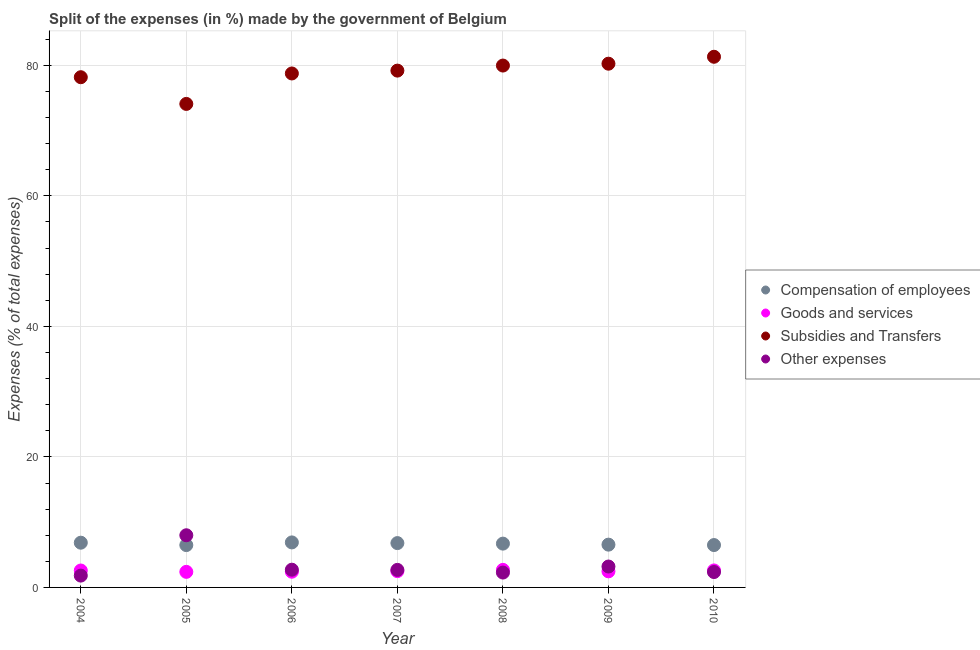How many different coloured dotlines are there?
Your answer should be very brief. 4. What is the percentage of amount spent on compensation of employees in 2005?
Provide a short and direct response. 6.49. Across all years, what is the maximum percentage of amount spent on subsidies?
Offer a terse response. 81.32. Across all years, what is the minimum percentage of amount spent on compensation of employees?
Give a very brief answer. 6.49. In which year was the percentage of amount spent on goods and services maximum?
Keep it short and to the point. 2008. In which year was the percentage of amount spent on compensation of employees minimum?
Make the answer very short. 2005. What is the total percentage of amount spent on goods and services in the graph?
Ensure brevity in your answer.  17.65. What is the difference between the percentage of amount spent on goods and services in 2006 and that in 2007?
Make the answer very short. -0.09. What is the difference between the percentage of amount spent on goods and services in 2010 and the percentage of amount spent on subsidies in 2006?
Keep it short and to the point. -76.16. What is the average percentage of amount spent on subsidies per year?
Your answer should be very brief. 78.83. In the year 2010, what is the difference between the percentage of amount spent on compensation of employees and percentage of amount spent on goods and services?
Offer a terse response. 3.89. In how many years, is the percentage of amount spent on compensation of employees greater than 76 %?
Your response must be concise. 0. What is the ratio of the percentage of amount spent on other expenses in 2006 to that in 2008?
Offer a terse response. 1.19. Is the percentage of amount spent on compensation of employees in 2004 less than that in 2007?
Make the answer very short. No. What is the difference between the highest and the second highest percentage of amount spent on goods and services?
Your response must be concise. 0.09. What is the difference between the highest and the lowest percentage of amount spent on goods and services?
Provide a succinct answer. 0.3. Is it the case that in every year, the sum of the percentage of amount spent on other expenses and percentage of amount spent on subsidies is greater than the sum of percentage of amount spent on goods and services and percentage of amount spent on compensation of employees?
Offer a terse response. Yes. Does the percentage of amount spent on compensation of employees monotonically increase over the years?
Your answer should be compact. No. How many years are there in the graph?
Provide a short and direct response. 7. What is the difference between two consecutive major ticks on the Y-axis?
Ensure brevity in your answer.  20. Are the values on the major ticks of Y-axis written in scientific E-notation?
Your answer should be very brief. No. Does the graph contain any zero values?
Your answer should be compact. No. How many legend labels are there?
Provide a short and direct response. 4. What is the title of the graph?
Ensure brevity in your answer.  Split of the expenses (in %) made by the government of Belgium. What is the label or title of the Y-axis?
Provide a short and direct response. Expenses (% of total expenses). What is the Expenses (% of total expenses) in Compensation of employees in 2004?
Your answer should be very brief. 6.85. What is the Expenses (% of total expenses) in Goods and services in 2004?
Your response must be concise. 2.59. What is the Expenses (% of total expenses) of Subsidies and Transfers in 2004?
Provide a short and direct response. 78.19. What is the Expenses (% of total expenses) in Other expenses in 2004?
Give a very brief answer. 1.81. What is the Expenses (% of total expenses) in Compensation of employees in 2005?
Your answer should be very brief. 6.49. What is the Expenses (% of total expenses) of Goods and services in 2005?
Provide a short and direct response. 2.39. What is the Expenses (% of total expenses) of Subsidies and Transfers in 2005?
Keep it short and to the point. 74.09. What is the Expenses (% of total expenses) of Other expenses in 2005?
Provide a succinct answer. 7.99. What is the Expenses (% of total expenses) of Compensation of employees in 2006?
Offer a very short reply. 6.9. What is the Expenses (% of total expenses) in Goods and services in 2006?
Provide a short and direct response. 2.41. What is the Expenses (% of total expenses) of Subsidies and Transfers in 2006?
Give a very brief answer. 78.76. What is the Expenses (% of total expenses) in Other expenses in 2006?
Keep it short and to the point. 2.72. What is the Expenses (% of total expenses) in Compensation of employees in 2007?
Your answer should be compact. 6.79. What is the Expenses (% of total expenses) in Goods and services in 2007?
Your response must be concise. 2.5. What is the Expenses (% of total expenses) in Subsidies and Transfers in 2007?
Your answer should be compact. 79.2. What is the Expenses (% of total expenses) of Other expenses in 2007?
Give a very brief answer. 2.69. What is the Expenses (% of total expenses) in Compensation of employees in 2008?
Make the answer very short. 6.71. What is the Expenses (% of total expenses) in Goods and services in 2008?
Offer a very short reply. 2.69. What is the Expenses (% of total expenses) in Subsidies and Transfers in 2008?
Your answer should be very brief. 79.97. What is the Expenses (% of total expenses) of Other expenses in 2008?
Your answer should be compact. 2.28. What is the Expenses (% of total expenses) in Compensation of employees in 2009?
Offer a terse response. 6.56. What is the Expenses (% of total expenses) of Goods and services in 2009?
Offer a very short reply. 2.47. What is the Expenses (% of total expenses) of Subsidies and Transfers in 2009?
Offer a very short reply. 80.26. What is the Expenses (% of total expenses) in Other expenses in 2009?
Your answer should be compact. 3.2. What is the Expenses (% of total expenses) of Compensation of employees in 2010?
Ensure brevity in your answer.  6.49. What is the Expenses (% of total expenses) of Goods and services in 2010?
Make the answer very short. 2.6. What is the Expenses (% of total expenses) of Subsidies and Transfers in 2010?
Make the answer very short. 81.32. What is the Expenses (% of total expenses) in Other expenses in 2010?
Give a very brief answer. 2.36. Across all years, what is the maximum Expenses (% of total expenses) in Compensation of employees?
Make the answer very short. 6.9. Across all years, what is the maximum Expenses (% of total expenses) of Goods and services?
Ensure brevity in your answer.  2.69. Across all years, what is the maximum Expenses (% of total expenses) of Subsidies and Transfers?
Ensure brevity in your answer.  81.32. Across all years, what is the maximum Expenses (% of total expenses) in Other expenses?
Provide a short and direct response. 7.99. Across all years, what is the minimum Expenses (% of total expenses) in Compensation of employees?
Ensure brevity in your answer.  6.49. Across all years, what is the minimum Expenses (% of total expenses) in Goods and services?
Your answer should be compact. 2.39. Across all years, what is the minimum Expenses (% of total expenses) in Subsidies and Transfers?
Make the answer very short. 74.09. Across all years, what is the minimum Expenses (% of total expenses) of Other expenses?
Give a very brief answer. 1.81. What is the total Expenses (% of total expenses) of Compensation of employees in the graph?
Make the answer very short. 46.8. What is the total Expenses (% of total expenses) in Goods and services in the graph?
Keep it short and to the point. 17.65. What is the total Expenses (% of total expenses) of Subsidies and Transfers in the graph?
Your answer should be very brief. 551.78. What is the total Expenses (% of total expenses) of Other expenses in the graph?
Make the answer very short. 23.05. What is the difference between the Expenses (% of total expenses) in Compensation of employees in 2004 and that in 2005?
Make the answer very short. 0.37. What is the difference between the Expenses (% of total expenses) of Goods and services in 2004 and that in 2005?
Your answer should be very brief. 0.21. What is the difference between the Expenses (% of total expenses) of Subsidies and Transfers in 2004 and that in 2005?
Your response must be concise. 4.09. What is the difference between the Expenses (% of total expenses) in Other expenses in 2004 and that in 2005?
Keep it short and to the point. -6.18. What is the difference between the Expenses (% of total expenses) in Compensation of employees in 2004 and that in 2006?
Make the answer very short. -0.04. What is the difference between the Expenses (% of total expenses) of Goods and services in 2004 and that in 2006?
Your answer should be compact. 0.18. What is the difference between the Expenses (% of total expenses) in Subsidies and Transfers in 2004 and that in 2006?
Provide a short and direct response. -0.57. What is the difference between the Expenses (% of total expenses) of Other expenses in 2004 and that in 2006?
Your response must be concise. -0.91. What is the difference between the Expenses (% of total expenses) in Compensation of employees in 2004 and that in 2007?
Keep it short and to the point. 0.06. What is the difference between the Expenses (% of total expenses) in Goods and services in 2004 and that in 2007?
Your answer should be compact. 0.09. What is the difference between the Expenses (% of total expenses) in Subsidies and Transfers in 2004 and that in 2007?
Offer a very short reply. -1.01. What is the difference between the Expenses (% of total expenses) of Other expenses in 2004 and that in 2007?
Keep it short and to the point. -0.88. What is the difference between the Expenses (% of total expenses) in Compensation of employees in 2004 and that in 2008?
Ensure brevity in your answer.  0.14. What is the difference between the Expenses (% of total expenses) in Goods and services in 2004 and that in 2008?
Make the answer very short. -0.1. What is the difference between the Expenses (% of total expenses) in Subsidies and Transfers in 2004 and that in 2008?
Your response must be concise. -1.79. What is the difference between the Expenses (% of total expenses) of Other expenses in 2004 and that in 2008?
Keep it short and to the point. -0.47. What is the difference between the Expenses (% of total expenses) in Compensation of employees in 2004 and that in 2009?
Give a very brief answer. 0.3. What is the difference between the Expenses (% of total expenses) of Goods and services in 2004 and that in 2009?
Your answer should be very brief. 0.13. What is the difference between the Expenses (% of total expenses) in Subsidies and Transfers in 2004 and that in 2009?
Your response must be concise. -2.07. What is the difference between the Expenses (% of total expenses) in Other expenses in 2004 and that in 2009?
Provide a succinct answer. -1.39. What is the difference between the Expenses (% of total expenses) of Compensation of employees in 2004 and that in 2010?
Your answer should be very brief. 0.36. What is the difference between the Expenses (% of total expenses) of Goods and services in 2004 and that in 2010?
Your answer should be compact. -0.01. What is the difference between the Expenses (% of total expenses) of Subsidies and Transfers in 2004 and that in 2010?
Offer a terse response. -3.13. What is the difference between the Expenses (% of total expenses) in Other expenses in 2004 and that in 2010?
Keep it short and to the point. -0.54. What is the difference between the Expenses (% of total expenses) of Compensation of employees in 2005 and that in 2006?
Your answer should be very brief. -0.41. What is the difference between the Expenses (% of total expenses) of Goods and services in 2005 and that in 2006?
Your answer should be compact. -0.02. What is the difference between the Expenses (% of total expenses) in Subsidies and Transfers in 2005 and that in 2006?
Offer a terse response. -4.67. What is the difference between the Expenses (% of total expenses) of Other expenses in 2005 and that in 2006?
Give a very brief answer. 5.28. What is the difference between the Expenses (% of total expenses) of Compensation of employees in 2005 and that in 2007?
Provide a succinct answer. -0.31. What is the difference between the Expenses (% of total expenses) in Goods and services in 2005 and that in 2007?
Keep it short and to the point. -0.11. What is the difference between the Expenses (% of total expenses) of Subsidies and Transfers in 2005 and that in 2007?
Ensure brevity in your answer.  -5.1. What is the difference between the Expenses (% of total expenses) in Other expenses in 2005 and that in 2007?
Offer a terse response. 5.31. What is the difference between the Expenses (% of total expenses) in Compensation of employees in 2005 and that in 2008?
Give a very brief answer. -0.22. What is the difference between the Expenses (% of total expenses) of Goods and services in 2005 and that in 2008?
Provide a succinct answer. -0.3. What is the difference between the Expenses (% of total expenses) in Subsidies and Transfers in 2005 and that in 2008?
Give a very brief answer. -5.88. What is the difference between the Expenses (% of total expenses) of Other expenses in 2005 and that in 2008?
Provide a succinct answer. 5.72. What is the difference between the Expenses (% of total expenses) in Compensation of employees in 2005 and that in 2009?
Give a very brief answer. -0.07. What is the difference between the Expenses (% of total expenses) in Goods and services in 2005 and that in 2009?
Keep it short and to the point. -0.08. What is the difference between the Expenses (% of total expenses) in Subsidies and Transfers in 2005 and that in 2009?
Offer a terse response. -6.16. What is the difference between the Expenses (% of total expenses) in Other expenses in 2005 and that in 2009?
Make the answer very short. 4.79. What is the difference between the Expenses (% of total expenses) in Compensation of employees in 2005 and that in 2010?
Offer a very short reply. -0. What is the difference between the Expenses (% of total expenses) of Goods and services in 2005 and that in 2010?
Ensure brevity in your answer.  -0.22. What is the difference between the Expenses (% of total expenses) in Subsidies and Transfers in 2005 and that in 2010?
Your answer should be compact. -7.23. What is the difference between the Expenses (% of total expenses) in Other expenses in 2005 and that in 2010?
Keep it short and to the point. 5.64. What is the difference between the Expenses (% of total expenses) of Compensation of employees in 2006 and that in 2007?
Give a very brief answer. 0.1. What is the difference between the Expenses (% of total expenses) of Goods and services in 2006 and that in 2007?
Offer a terse response. -0.09. What is the difference between the Expenses (% of total expenses) in Subsidies and Transfers in 2006 and that in 2007?
Ensure brevity in your answer.  -0.44. What is the difference between the Expenses (% of total expenses) in Other expenses in 2006 and that in 2007?
Provide a succinct answer. 0.03. What is the difference between the Expenses (% of total expenses) of Compensation of employees in 2006 and that in 2008?
Your response must be concise. 0.19. What is the difference between the Expenses (% of total expenses) of Goods and services in 2006 and that in 2008?
Give a very brief answer. -0.28. What is the difference between the Expenses (% of total expenses) of Subsidies and Transfers in 2006 and that in 2008?
Keep it short and to the point. -1.21. What is the difference between the Expenses (% of total expenses) of Other expenses in 2006 and that in 2008?
Keep it short and to the point. 0.44. What is the difference between the Expenses (% of total expenses) in Compensation of employees in 2006 and that in 2009?
Provide a succinct answer. 0.34. What is the difference between the Expenses (% of total expenses) in Goods and services in 2006 and that in 2009?
Provide a short and direct response. -0.06. What is the difference between the Expenses (% of total expenses) in Subsidies and Transfers in 2006 and that in 2009?
Offer a terse response. -1.5. What is the difference between the Expenses (% of total expenses) in Other expenses in 2006 and that in 2009?
Make the answer very short. -0.49. What is the difference between the Expenses (% of total expenses) in Compensation of employees in 2006 and that in 2010?
Provide a succinct answer. 0.41. What is the difference between the Expenses (% of total expenses) of Goods and services in 2006 and that in 2010?
Keep it short and to the point. -0.19. What is the difference between the Expenses (% of total expenses) in Subsidies and Transfers in 2006 and that in 2010?
Provide a succinct answer. -2.56. What is the difference between the Expenses (% of total expenses) in Other expenses in 2006 and that in 2010?
Provide a succinct answer. 0.36. What is the difference between the Expenses (% of total expenses) of Compensation of employees in 2007 and that in 2008?
Your response must be concise. 0.08. What is the difference between the Expenses (% of total expenses) of Goods and services in 2007 and that in 2008?
Keep it short and to the point. -0.19. What is the difference between the Expenses (% of total expenses) of Subsidies and Transfers in 2007 and that in 2008?
Your answer should be very brief. -0.77. What is the difference between the Expenses (% of total expenses) in Other expenses in 2007 and that in 2008?
Your response must be concise. 0.41. What is the difference between the Expenses (% of total expenses) of Compensation of employees in 2007 and that in 2009?
Your response must be concise. 0.24. What is the difference between the Expenses (% of total expenses) in Goods and services in 2007 and that in 2009?
Offer a terse response. 0.03. What is the difference between the Expenses (% of total expenses) of Subsidies and Transfers in 2007 and that in 2009?
Provide a succinct answer. -1.06. What is the difference between the Expenses (% of total expenses) in Other expenses in 2007 and that in 2009?
Keep it short and to the point. -0.52. What is the difference between the Expenses (% of total expenses) in Compensation of employees in 2007 and that in 2010?
Give a very brief answer. 0.3. What is the difference between the Expenses (% of total expenses) in Goods and services in 2007 and that in 2010?
Offer a terse response. -0.1. What is the difference between the Expenses (% of total expenses) of Subsidies and Transfers in 2007 and that in 2010?
Provide a short and direct response. -2.12. What is the difference between the Expenses (% of total expenses) in Other expenses in 2007 and that in 2010?
Provide a succinct answer. 0.33. What is the difference between the Expenses (% of total expenses) in Compensation of employees in 2008 and that in 2009?
Your answer should be very brief. 0.16. What is the difference between the Expenses (% of total expenses) in Goods and services in 2008 and that in 2009?
Offer a very short reply. 0.22. What is the difference between the Expenses (% of total expenses) of Subsidies and Transfers in 2008 and that in 2009?
Ensure brevity in your answer.  -0.29. What is the difference between the Expenses (% of total expenses) in Other expenses in 2008 and that in 2009?
Ensure brevity in your answer.  -0.93. What is the difference between the Expenses (% of total expenses) in Compensation of employees in 2008 and that in 2010?
Ensure brevity in your answer.  0.22. What is the difference between the Expenses (% of total expenses) of Goods and services in 2008 and that in 2010?
Your answer should be compact. 0.09. What is the difference between the Expenses (% of total expenses) in Subsidies and Transfers in 2008 and that in 2010?
Offer a very short reply. -1.35. What is the difference between the Expenses (% of total expenses) of Other expenses in 2008 and that in 2010?
Make the answer very short. -0.08. What is the difference between the Expenses (% of total expenses) of Compensation of employees in 2009 and that in 2010?
Ensure brevity in your answer.  0.06. What is the difference between the Expenses (% of total expenses) in Goods and services in 2009 and that in 2010?
Your response must be concise. -0.14. What is the difference between the Expenses (% of total expenses) of Subsidies and Transfers in 2009 and that in 2010?
Ensure brevity in your answer.  -1.06. What is the difference between the Expenses (% of total expenses) in Other expenses in 2009 and that in 2010?
Your answer should be very brief. 0.85. What is the difference between the Expenses (% of total expenses) of Compensation of employees in 2004 and the Expenses (% of total expenses) of Goods and services in 2005?
Offer a terse response. 4.47. What is the difference between the Expenses (% of total expenses) of Compensation of employees in 2004 and the Expenses (% of total expenses) of Subsidies and Transfers in 2005?
Make the answer very short. -67.24. What is the difference between the Expenses (% of total expenses) of Compensation of employees in 2004 and the Expenses (% of total expenses) of Other expenses in 2005?
Provide a succinct answer. -1.14. What is the difference between the Expenses (% of total expenses) of Goods and services in 2004 and the Expenses (% of total expenses) of Subsidies and Transfers in 2005?
Your answer should be compact. -71.5. What is the difference between the Expenses (% of total expenses) of Goods and services in 2004 and the Expenses (% of total expenses) of Other expenses in 2005?
Your answer should be compact. -5.4. What is the difference between the Expenses (% of total expenses) of Subsidies and Transfers in 2004 and the Expenses (% of total expenses) of Other expenses in 2005?
Offer a very short reply. 70.19. What is the difference between the Expenses (% of total expenses) of Compensation of employees in 2004 and the Expenses (% of total expenses) of Goods and services in 2006?
Give a very brief answer. 4.45. What is the difference between the Expenses (% of total expenses) of Compensation of employees in 2004 and the Expenses (% of total expenses) of Subsidies and Transfers in 2006?
Your answer should be very brief. -71.91. What is the difference between the Expenses (% of total expenses) in Compensation of employees in 2004 and the Expenses (% of total expenses) in Other expenses in 2006?
Make the answer very short. 4.14. What is the difference between the Expenses (% of total expenses) of Goods and services in 2004 and the Expenses (% of total expenses) of Subsidies and Transfers in 2006?
Offer a very short reply. -76.17. What is the difference between the Expenses (% of total expenses) of Goods and services in 2004 and the Expenses (% of total expenses) of Other expenses in 2006?
Your answer should be compact. -0.13. What is the difference between the Expenses (% of total expenses) in Subsidies and Transfers in 2004 and the Expenses (% of total expenses) in Other expenses in 2006?
Offer a very short reply. 75.47. What is the difference between the Expenses (% of total expenses) of Compensation of employees in 2004 and the Expenses (% of total expenses) of Goods and services in 2007?
Provide a succinct answer. 4.35. What is the difference between the Expenses (% of total expenses) in Compensation of employees in 2004 and the Expenses (% of total expenses) in Subsidies and Transfers in 2007?
Give a very brief answer. -72.34. What is the difference between the Expenses (% of total expenses) in Compensation of employees in 2004 and the Expenses (% of total expenses) in Other expenses in 2007?
Ensure brevity in your answer.  4.17. What is the difference between the Expenses (% of total expenses) in Goods and services in 2004 and the Expenses (% of total expenses) in Subsidies and Transfers in 2007?
Keep it short and to the point. -76.6. What is the difference between the Expenses (% of total expenses) of Goods and services in 2004 and the Expenses (% of total expenses) of Other expenses in 2007?
Offer a terse response. -0.1. What is the difference between the Expenses (% of total expenses) of Subsidies and Transfers in 2004 and the Expenses (% of total expenses) of Other expenses in 2007?
Your response must be concise. 75.5. What is the difference between the Expenses (% of total expenses) in Compensation of employees in 2004 and the Expenses (% of total expenses) in Goods and services in 2008?
Your response must be concise. 4.16. What is the difference between the Expenses (% of total expenses) in Compensation of employees in 2004 and the Expenses (% of total expenses) in Subsidies and Transfers in 2008?
Your answer should be compact. -73.12. What is the difference between the Expenses (% of total expenses) of Compensation of employees in 2004 and the Expenses (% of total expenses) of Other expenses in 2008?
Provide a succinct answer. 4.58. What is the difference between the Expenses (% of total expenses) in Goods and services in 2004 and the Expenses (% of total expenses) in Subsidies and Transfers in 2008?
Ensure brevity in your answer.  -77.38. What is the difference between the Expenses (% of total expenses) in Goods and services in 2004 and the Expenses (% of total expenses) in Other expenses in 2008?
Keep it short and to the point. 0.32. What is the difference between the Expenses (% of total expenses) of Subsidies and Transfers in 2004 and the Expenses (% of total expenses) of Other expenses in 2008?
Offer a very short reply. 75.91. What is the difference between the Expenses (% of total expenses) in Compensation of employees in 2004 and the Expenses (% of total expenses) in Goods and services in 2009?
Make the answer very short. 4.39. What is the difference between the Expenses (% of total expenses) in Compensation of employees in 2004 and the Expenses (% of total expenses) in Subsidies and Transfers in 2009?
Provide a succinct answer. -73.4. What is the difference between the Expenses (% of total expenses) in Compensation of employees in 2004 and the Expenses (% of total expenses) in Other expenses in 2009?
Provide a succinct answer. 3.65. What is the difference between the Expenses (% of total expenses) of Goods and services in 2004 and the Expenses (% of total expenses) of Subsidies and Transfers in 2009?
Make the answer very short. -77.66. What is the difference between the Expenses (% of total expenses) of Goods and services in 2004 and the Expenses (% of total expenses) of Other expenses in 2009?
Make the answer very short. -0.61. What is the difference between the Expenses (% of total expenses) of Subsidies and Transfers in 2004 and the Expenses (% of total expenses) of Other expenses in 2009?
Provide a short and direct response. 74.98. What is the difference between the Expenses (% of total expenses) in Compensation of employees in 2004 and the Expenses (% of total expenses) in Goods and services in 2010?
Keep it short and to the point. 4.25. What is the difference between the Expenses (% of total expenses) of Compensation of employees in 2004 and the Expenses (% of total expenses) of Subsidies and Transfers in 2010?
Offer a very short reply. -74.46. What is the difference between the Expenses (% of total expenses) in Compensation of employees in 2004 and the Expenses (% of total expenses) in Other expenses in 2010?
Offer a very short reply. 4.5. What is the difference between the Expenses (% of total expenses) of Goods and services in 2004 and the Expenses (% of total expenses) of Subsidies and Transfers in 2010?
Provide a short and direct response. -78.73. What is the difference between the Expenses (% of total expenses) in Goods and services in 2004 and the Expenses (% of total expenses) in Other expenses in 2010?
Offer a terse response. 0.24. What is the difference between the Expenses (% of total expenses) in Subsidies and Transfers in 2004 and the Expenses (% of total expenses) in Other expenses in 2010?
Ensure brevity in your answer.  75.83. What is the difference between the Expenses (% of total expenses) of Compensation of employees in 2005 and the Expenses (% of total expenses) of Goods and services in 2006?
Your response must be concise. 4.08. What is the difference between the Expenses (% of total expenses) of Compensation of employees in 2005 and the Expenses (% of total expenses) of Subsidies and Transfers in 2006?
Provide a succinct answer. -72.27. What is the difference between the Expenses (% of total expenses) in Compensation of employees in 2005 and the Expenses (% of total expenses) in Other expenses in 2006?
Keep it short and to the point. 3.77. What is the difference between the Expenses (% of total expenses) of Goods and services in 2005 and the Expenses (% of total expenses) of Subsidies and Transfers in 2006?
Your answer should be very brief. -76.37. What is the difference between the Expenses (% of total expenses) in Goods and services in 2005 and the Expenses (% of total expenses) in Other expenses in 2006?
Your answer should be very brief. -0.33. What is the difference between the Expenses (% of total expenses) in Subsidies and Transfers in 2005 and the Expenses (% of total expenses) in Other expenses in 2006?
Keep it short and to the point. 71.37. What is the difference between the Expenses (% of total expenses) in Compensation of employees in 2005 and the Expenses (% of total expenses) in Goods and services in 2007?
Make the answer very short. 3.99. What is the difference between the Expenses (% of total expenses) of Compensation of employees in 2005 and the Expenses (% of total expenses) of Subsidies and Transfers in 2007?
Your answer should be very brief. -72.71. What is the difference between the Expenses (% of total expenses) in Compensation of employees in 2005 and the Expenses (% of total expenses) in Other expenses in 2007?
Give a very brief answer. 3.8. What is the difference between the Expenses (% of total expenses) of Goods and services in 2005 and the Expenses (% of total expenses) of Subsidies and Transfers in 2007?
Provide a short and direct response. -76.81. What is the difference between the Expenses (% of total expenses) in Goods and services in 2005 and the Expenses (% of total expenses) in Other expenses in 2007?
Your response must be concise. -0.3. What is the difference between the Expenses (% of total expenses) of Subsidies and Transfers in 2005 and the Expenses (% of total expenses) of Other expenses in 2007?
Offer a terse response. 71.4. What is the difference between the Expenses (% of total expenses) in Compensation of employees in 2005 and the Expenses (% of total expenses) in Goods and services in 2008?
Your answer should be compact. 3.8. What is the difference between the Expenses (% of total expenses) of Compensation of employees in 2005 and the Expenses (% of total expenses) of Subsidies and Transfers in 2008?
Your answer should be compact. -73.48. What is the difference between the Expenses (% of total expenses) in Compensation of employees in 2005 and the Expenses (% of total expenses) in Other expenses in 2008?
Make the answer very short. 4.21. What is the difference between the Expenses (% of total expenses) in Goods and services in 2005 and the Expenses (% of total expenses) in Subsidies and Transfers in 2008?
Provide a succinct answer. -77.58. What is the difference between the Expenses (% of total expenses) of Goods and services in 2005 and the Expenses (% of total expenses) of Other expenses in 2008?
Your response must be concise. 0.11. What is the difference between the Expenses (% of total expenses) in Subsidies and Transfers in 2005 and the Expenses (% of total expenses) in Other expenses in 2008?
Give a very brief answer. 71.82. What is the difference between the Expenses (% of total expenses) in Compensation of employees in 2005 and the Expenses (% of total expenses) in Goods and services in 2009?
Provide a succinct answer. 4.02. What is the difference between the Expenses (% of total expenses) in Compensation of employees in 2005 and the Expenses (% of total expenses) in Subsidies and Transfers in 2009?
Your response must be concise. -73.77. What is the difference between the Expenses (% of total expenses) of Compensation of employees in 2005 and the Expenses (% of total expenses) of Other expenses in 2009?
Ensure brevity in your answer.  3.28. What is the difference between the Expenses (% of total expenses) of Goods and services in 2005 and the Expenses (% of total expenses) of Subsidies and Transfers in 2009?
Make the answer very short. -77.87. What is the difference between the Expenses (% of total expenses) of Goods and services in 2005 and the Expenses (% of total expenses) of Other expenses in 2009?
Provide a succinct answer. -0.82. What is the difference between the Expenses (% of total expenses) in Subsidies and Transfers in 2005 and the Expenses (% of total expenses) in Other expenses in 2009?
Offer a terse response. 70.89. What is the difference between the Expenses (% of total expenses) in Compensation of employees in 2005 and the Expenses (% of total expenses) in Goods and services in 2010?
Make the answer very short. 3.88. What is the difference between the Expenses (% of total expenses) in Compensation of employees in 2005 and the Expenses (% of total expenses) in Subsidies and Transfers in 2010?
Give a very brief answer. -74.83. What is the difference between the Expenses (% of total expenses) in Compensation of employees in 2005 and the Expenses (% of total expenses) in Other expenses in 2010?
Make the answer very short. 4.13. What is the difference between the Expenses (% of total expenses) in Goods and services in 2005 and the Expenses (% of total expenses) in Subsidies and Transfers in 2010?
Offer a terse response. -78.93. What is the difference between the Expenses (% of total expenses) of Goods and services in 2005 and the Expenses (% of total expenses) of Other expenses in 2010?
Provide a succinct answer. 0.03. What is the difference between the Expenses (% of total expenses) in Subsidies and Transfers in 2005 and the Expenses (% of total expenses) in Other expenses in 2010?
Your response must be concise. 71.74. What is the difference between the Expenses (% of total expenses) of Compensation of employees in 2006 and the Expenses (% of total expenses) of Goods and services in 2007?
Offer a terse response. 4.4. What is the difference between the Expenses (% of total expenses) in Compensation of employees in 2006 and the Expenses (% of total expenses) in Subsidies and Transfers in 2007?
Offer a very short reply. -72.3. What is the difference between the Expenses (% of total expenses) of Compensation of employees in 2006 and the Expenses (% of total expenses) of Other expenses in 2007?
Offer a very short reply. 4.21. What is the difference between the Expenses (% of total expenses) of Goods and services in 2006 and the Expenses (% of total expenses) of Subsidies and Transfers in 2007?
Offer a terse response. -76.79. What is the difference between the Expenses (% of total expenses) of Goods and services in 2006 and the Expenses (% of total expenses) of Other expenses in 2007?
Offer a terse response. -0.28. What is the difference between the Expenses (% of total expenses) of Subsidies and Transfers in 2006 and the Expenses (% of total expenses) of Other expenses in 2007?
Your answer should be very brief. 76.07. What is the difference between the Expenses (% of total expenses) of Compensation of employees in 2006 and the Expenses (% of total expenses) of Goods and services in 2008?
Your answer should be very brief. 4.21. What is the difference between the Expenses (% of total expenses) in Compensation of employees in 2006 and the Expenses (% of total expenses) in Subsidies and Transfers in 2008?
Ensure brevity in your answer.  -73.07. What is the difference between the Expenses (% of total expenses) of Compensation of employees in 2006 and the Expenses (% of total expenses) of Other expenses in 2008?
Your answer should be very brief. 4.62. What is the difference between the Expenses (% of total expenses) of Goods and services in 2006 and the Expenses (% of total expenses) of Subsidies and Transfers in 2008?
Your response must be concise. -77.56. What is the difference between the Expenses (% of total expenses) in Goods and services in 2006 and the Expenses (% of total expenses) in Other expenses in 2008?
Keep it short and to the point. 0.13. What is the difference between the Expenses (% of total expenses) of Subsidies and Transfers in 2006 and the Expenses (% of total expenses) of Other expenses in 2008?
Provide a short and direct response. 76.48. What is the difference between the Expenses (% of total expenses) in Compensation of employees in 2006 and the Expenses (% of total expenses) in Goods and services in 2009?
Keep it short and to the point. 4.43. What is the difference between the Expenses (% of total expenses) of Compensation of employees in 2006 and the Expenses (% of total expenses) of Subsidies and Transfers in 2009?
Give a very brief answer. -73.36. What is the difference between the Expenses (% of total expenses) in Compensation of employees in 2006 and the Expenses (% of total expenses) in Other expenses in 2009?
Give a very brief answer. 3.69. What is the difference between the Expenses (% of total expenses) of Goods and services in 2006 and the Expenses (% of total expenses) of Subsidies and Transfers in 2009?
Provide a short and direct response. -77.85. What is the difference between the Expenses (% of total expenses) in Goods and services in 2006 and the Expenses (% of total expenses) in Other expenses in 2009?
Offer a terse response. -0.79. What is the difference between the Expenses (% of total expenses) of Subsidies and Transfers in 2006 and the Expenses (% of total expenses) of Other expenses in 2009?
Your answer should be very brief. 75.56. What is the difference between the Expenses (% of total expenses) in Compensation of employees in 2006 and the Expenses (% of total expenses) in Goods and services in 2010?
Your answer should be compact. 4.3. What is the difference between the Expenses (% of total expenses) of Compensation of employees in 2006 and the Expenses (% of total expenses) of Subsidies and Transfers in 2010?
Provide a succinct answer. -74.42. What is the difference between the Expenses (% of total expenses) in Compensation of employees in 2006 and the Expenses (% of total expenses) in Other expenses in 2010?
Ensure brevity in your answer.  4.54. What is the difference between the Expenses (% of total expenses) of Goods and services in 2006 and the Expenses (% of total expenses) of Subsidies and Transfers in 2010?
Your answer should be compact. -78.91. What is the difference between the Expenses (% of total expenses) of Goods and services in 2006 and the Expenses (% of total expenses) of Other expenses in 2010?
Provide a succinct answer. 0.05. What is the difference between the Expenses (% of total expenses) in Subsidies and Transfers in 2006 and the Expenses (% of total expenses) in Other expenses in 2010?
Keep it short and to the point. 76.4. What is the difference between the Expenses (% of total expenses) of Compensation of employees in 2007 and the Expenses (% of total expenses) of Goods and services in 2008?
Keep it short and to the point. 4.1. What is the difference between the Expenses (% of total expenses) of Compensation of employees in 2007 and the Expenses (% of total expenses) of Subsidies and Transfers in 2008?
Keep it short and to the point. -73.18. What is the difference between the Expenses (% of total expenses) in Compensation of employees in 2007 and the Expenses (% of total expenses) in Other expenses in 2008?
Ensure brevity in your answer.  4.52. What is the difference between the Expenses (% of total expenses) of Goods and services in 2007 and the Expenses (% of total expenses) of Subsidies and Transfers in 2008?
Offer a very short reply. -77.47. What is the difference between the Expenses (% of total expenses) in Goods and services in 2007 and the Expenses (% of total expenses) in Other expenses in 2008?
Provide a short and direct response. 0.22. What is the difference between the Expenses (% of total expenses) of Subsidies and Transfers in 2007 and the Expenses (% of total expenses) of Other expenses in 2008?
Provide a short and direct response. 76.92. What is the difference between the Expenses (% of total expenses) of Compensation of employees in 2007 and the Expenses (% of total expenses) of Goods and services in 2009?
Ensure brevity in your answer.  4.33. What is the difference between the Expenses (% of total expenses) of Compensation of employees in 2007 and the Expenses (% of total expenses) of Subsidies and Transfers in 2009?
Your answer should be compact. -73.46. What is the difference between the Expenses (% of total expenses) in Compensation of employees in 2007 and the Expenses (% of total expenses) in Other expenses in 2009?
Keep it short and to the point. 3.59. What is the difference between the Expenses (% of total expenses) of Goods and services in 2007 and the Expenses (% of total expenses) of Subsidies and Transfers in 2009?
Your answer should be very brief. -77.76. What is the difference between the Expenses (% of total expenses) in Goods and services in 2007 and the Expenses (% of total expenses) in Other expenses in 2009?
Keep it short and to the point. -0.7. What is the difference between the Expenses (% of total expenses) of Subsidies and Transfers in 2007 and the Expenses (% of total expenses) of Other expenses in 2009?
Keep it short and to the point. 75.99. What is the difference between the Expenses (% of total expenses) of Compensation of employees in 2007 and the Expenses (% of total expenses) of Goods and services in 2010?
Offer a very short reply. 4.19. What is the difference between the Expenses (% of total expenses) of Compensation of employees in 2007 and the Expenses (% of total expenses) of Subsidies and Transfers in 2010?
Offer a very short reply. -74.52. What is the difference between the Expenses (% of total expenses) of Compensation of employees in 2007 and the Expenses (% of total expenses) of Other expenses in 2010?
Provide a succinct answer. 4.44. What is the difference between the Expenses (% of total expenses) of Goods and services in 2007 and the Expenses (% of total expenses) of Subsidies and Transfers in 2010?
Your response must be concise. -78.82. What is the difference between the Expenses (% of total expenses) of Goods and services in 2007 and the Expenses (% of total expenses) of Other expenses in 2010?
Your response must be concise. 0.14. What is the difference between the Expenses (% of total expenses) in Subsidies and Transfers in 2007 and the Expenses (% of total expenses) in Other expenses in 2010?
Your answer should be very brief. 76.84. What is the difference between the Expenses (% of total expenses) of Compensation of employees in 2008 and the Expenses (% of total expenses) of Goods and services in 2009?
Offer a terse response. 4.25. What is the difference between the Expenses (% of total expenses) of Compensation of employees in 2008 and the Expenses (% of total expenses) of Subsidies and Transfers in 2009?
Your answer should be very brief. -73.54. What is the difference between the Expenses (% of total expenses) in Compensation of employees in 2008 and the Expenses (% of total expenses) in Other expenses in 2009?
Ensure brevity in your answer.  3.51. What is the difference between the Expenses (% of total expenses) of Goods and services in 2008 and the Expenses (% of total expenses) of Subsidies and Transfers in 2009?
Your answer should be very brief. -77.57. What is the difference between the Expenses (% of total expenses) of Goods and services in 2008 and the Expenses (% of total expenses) of Other expenses in 2009?
Offer a terse response. -0.51. What is the difference between the Expenses (% of total expenses) of Subsidies and Transfers in 2008 and the Expenses (% of total expenses) of Other expenses in 2009?
Give a very brief answer. 76.77. What is the difference between the Expenses (% of total expenses) of Compensation of employees in 2008 and the Expenses (% of total expenses) of Goods and services in 2010?
Provide a succinct answer. 4.11. What is the difference between the Expenses (% of total expenses) of Compensation of employees in 2008 and the Expenses (% of total expenses) of Subsidies and Transfers in 2010?
Offer a very short reply. -74.61. What is the difference between the Expenses (% of total expenses) in Compensation of employees in 2008 and the Expenses (% of total expenses) in Other expenses in 2010?
Your answer should be compact. 4.36. What is the difference between the Expenses (% of total expenses) of Goods and services in 2008 and the Expenses (% of total expenses) of Subsidies and Transfers in 2010?
Offer a terse response. -78.63. What is the difference between the Expenses (% of total expenses) of Goods and services in 2008 and the Expenses (% of total expenses) of Other expenses in 2010?
Offer a terse response. 0.33. What is the difference between the Expenses (% of total expenses) in Subsidies and Transfers in 2008 and the Expenses (% of total expenses) in Other expenses in 2010?
Offer a very short reply. 77.61. What is the difference between the Expenses (% of total expenses) of Compensation of employees in 2009 and the Expenses (% of total expenses) of Goods and services in 2010?
Your answer should be very brief. 3.95. What is the difference between the Expenses (% of total expenses) in Compensation of employees in 2009 and the Expenses (% of total expenses) in Subsidies and Transfers in 2010?
Your answer should be very brief. -74.76. What is the difference between the Expenses (% of total expenses) in Compensation of employees in 2009 and the Expenses (% of total expenses) in Other expenses in 2010?
Offer a terse response. 4.2. What is the difference between the Expenses (% of total expenses) of Goods and services in 2009 and the Expenses (% of total expenses) of Subsidies and Transfers in 2010?
Give a very brief answer. -78.85. What is the difference between the Expenses (% of total expenses) in Goods and services in 2009 and the Expenses (% of total expenses) in Other expenses in 2010?
Make the answer very short. 0.11. What is the difference between the Expenses (% of total expenses) in Subsidies and Transfers in 2009 and the Expenses (% of total expenses) in Other expenses in 2010?
Your answer should be very brief. 77.9. What is the average Expenses (% of total expenses) of Compensation of employees per year?
Give a very brief answer. 6.69. What is the average Expenses (% of total expenses) of Goods and services per year?
Ensure brevity in your answer.  2.52. What is the average Expenses (% of total expenses) of Subsidies and Transfers per year?
Keep it short and to the point. 78.83. What is the average Expenses (% of total expenses) in Other expenses per year?
Ensure brevity in your answer.  3.29. In the year 2004, what is the difference between the Expenses (% of total expenses) of Compensation of employees and Expenses (% of total expenses) of Goods and services?
Give a very brief answer. 4.26. In the year 2004, what is the difference between the Expenses (% of total expenses) in Compensation of employees and Expenses (% of total expenses) in Subsidies and Transfers?
Your answer should be compact. -71.33. In the year 2004, what is the difference between the Expenses (% of total expenses) in Compensation of employees and Expenses (% of total expenses) in Other expenses?
Your response must be concise. 5.04. In the year 2004, what is the difference between the Expenses (% of total expenses) in Goods and services and Expenses (% of total expenses) in Subsidies and Transfers?
Offer a terse response. -75.59. In the year 2004, what is the difference between the Expenses (% of total expenses) of Goods and services and Expenses (% of total expenses) of Other expenses?
Keep it short and to the point. 0.78. In the year 2004, what is the difference between the Expenses (% of total expenses) of Subsidies and Transfers and Expenses (% of total expenses) of Other expenses?
Give a very brief answer. 76.37. In the year 2005, what is the difference between the Expenses (% of total expenses) in Compensation of employees and Expenses (% of total expenses) in Goods and services?
Keep it short and to the point. 4.1. In the year 2005, what is the difference between the Expenses (% of total expenses) in Compensation of employees and Expenses (% of total expenses) in Subsidies and Transfers?
Offer a terse response. -67.6. In the year 2005, what is the difference between the Expenses (% of total expenses) in Compensation of employees and Expenses (% of total expenses) in Other expenses?
Ensure brevity in your answer.  -1.51. In the year 2005, what is the difference between the Expenses (% of total expenses) in Goods and services and Expenses (% of total expenses) in Subsidies and Transfers?
Your response must be concise. -71.71. In the year 2005, what is the difference between the Expenses (% of total expenses) of Goods and services and Expenses (% of total expenses) of Other expenses?
Provide a succinct answer. -5.61. In the year 2005, what is the difference between the Expenses (% of total expenses) of Subsidies and Transfers and Expenses (% of total expenses) of Other expenses?
Give a very brief answer. 66.1. In the year 2006, what is the difference between the Expenses (% of total expenses) of Compensation of employees and Expenses (% of total expenses) of Goods and services?
Offer a terse response. 4.49. In the year 2006, what is the difference between the Expenses (% of total expenses) of Compensation of employees and Expenses (% of total expenses) of Subsidies and Transfers?
Make the answer very short. -71.86. In the year 2006, what is the difference between the Expenses (% of total expenses) of Compensation of employees and Expenses (% of total expenses) of Other expenses?
Offer a terse response. 4.18. In the year 2006, what is the difference between the Expenses (% of total expenses) in Goods and services and Expenses (% of total expenses) in Subsidies and Transfers?
Give a very brief answer. -76.35. In the year 2006, what is the difference between the Expenses (% of total expenses) in Goods and services and Expenses (% of total expenses) in Other expenses?
Provide a succinct answer. -0.31. In the year 2006, what is the difference between the Expenses (% of total expenses) in Subsidies and Transfers and Expenses (% of total expenses) in Other expenses?
Provide a short and direct response. 76.04. In the year 2007, what is the difference between the Expenses (% of total expenses) in Compensation of employees and Expenses (% of total expenses) in Goods and services?
Give a very brief answer. 4.29. In the year 2007, what is the difference between the Expenses (% of total expenses) in Compensation of employees and Expenses (% of total expenses) in Subsidies and Transfers?
Give a very brief answer. -72.4. In the year 2007, what is the difference between the Expenses (% of total expenses) in Compensation of employees and Expenses (% of total expenses) in Other expenses?
Keep it short and to the point. 4.11. In the year 2007, what is the difference between the Expenses (% of total expenses) in Goods and services and Expenses (% of total expenses) in Subsidies and Transfers?
Your answer should be very brief. -76.7. In the year 2007, what is the difference between the Expenses (% of total expenses) of Goods and services and Expenses (% of total expenses) of Other expenses?
Give a very brief answer. -0.19. In the year 2007, what is the difference between the Expenses (% of total expenses) in Subsidies and Transfers and Expenses (% of total expenses) in Other expenses?
Your answer should be compact. 76.51. In the year 2008, what is the difference between the Expenses (% of total expenses) of Compensation of employees and Expenses (% of total expenses) of Goods and services?
Offer a terse response. 4.02. In the year 2008, what is the difference between the Expenses (% of total expenses) in Compensation of employees and Expenses (% of total expenses) in Subsidies and Transfers?
Make the answer very short. -73.26. In the year 2008, what is the difference between the Expenses (% of total expenses) in Compensation of employees and Expenses (% of total expenses) in Other expenses?
Offer a terse response. 4.44. In the year 2008, what is the difference between the Expenses (% of total expenses) of Goods and services and Expenses (% of total expenses) of Subsidies and Transfers?
Ensure brevity in your answer.  -77.28. In the year 2008, what is the difference between the Expenses (% of total expenses) in Goods and services and Expenses (% of total expenses) in Other expenses?
Offer a very short reply. 0.41. In the year 2008, what is the difference between the Expenses (% of total expenses) in Subsidies and Transfers and Expenses (% of total expenses) in Other expenses?
Keep it short and to the point. 77.69. In the year 2009, what is the difference between the Expenses (% of total expenses) in Compensation of employees and Expenses (% of total expenses) in Goods and services?
Make the answer very short. 4.09. In the year 2009, what is the difference between the Expenses (% of total expenses) of Compensation of employees and Expenses (% of total expenses) of Subsidies and Transfers?
Your answer should be very brief. -73.7. In the year 2009, what is the difference between the Expenses (% of total expenses) of Compensation of employees and Expenses (% of total expenses) of Other expenses?
Your response must be concise. 3.35. In the year 2009, what is the difference between the Expenses (% of total expenses) in Goods and services and Expenses (% of total expenses) in Subsidies and Transfers?
Give a very brief answer. -77.79. In the year 2009, what is the difference between the Expenses (% of total expenses) in Goods and services and Expenses (% of total expenses) in Other expenses?
Make the answer very short. -0.74. In the year 2009, what is the difference between the Expenses (% of total expenses) of Subsidies and Transfers and Expenses (% of total expenses) of Other expenses?
Provide a short and direct response. 77.05. In the year 2010, what is the difference between the Expenses (% of total expenses) in Compensation of employees and Expenses (% of total expenses) in Goods and services?
Ensure brevity in your answer.  3.89. In the year 2010, what is the difference between the Expenses (% of total expenses) in Compensation of employees and Expenses (% of total expenses) in Subsidies and Transfers?
Give a very brief answer. -74.83. In the year 2010, what is the difference between the Expenses (% of total expenses) in Compensation of employees and Expenses (% of total expenses) in Other expenses?
Make the answer very short. 4.14. In the year 2010, what is the difference between the Expenses (% of total expenses) of Goods and services and Expenses (% of total expenses) of Subsidies and Transfers?
Offer a very short reply. -78.72. In the year 2010, what is the difference between the Expenses (% of total expenses) of Goods and services and Expenses (% of total expenses) of Other expenses?
Offer a very short reply. 0.25. In the year 2010, what is the difference between the Expenses (% of total expenses) of Subsidies and Transfers and Expenses (% of total expenses) of Other expenses?
Offer a very short reply. 78.96. What is the ratio of the Expenses (% of total expenses) in Compensation of employees in 2004 to that in 2005?
Your response must be concise. 1.06. What is the ratio of the Expenses (% of total expenses) of Goods and services in 2004 to that in 2005?
Your answer should be very brief. 1.09. What is the ratio of the Expenses (% of total expenses) in Subsidies and Transfers in 2004 to that in 2005?
Make the answer very short. 1.06. What is the ratio of the Expenses (% of total expenses) in Other expenses in 2004 to that in 2005?
Your answer should be compact. 0.23. What is the ratio of the Expenses (% of total expenses) in Goods and services in 2004 to that in 2006?
Provide a short and direct response. 1.08. What is the ratio of the Expenses (% of total expenses) of Subsidies and Transfers in 2004 to that in 2006?
Give a very brief answer. 0.99. What is the ratio of the Expenses (% of total expenses) of Other expenses in 2004 to that in 2006?
Provide a succinct answer. 0.67. What is the ratio of the Expenses (% of total expenses) of Compensation of employees in 2004 to that in 2007?
Ensure brevity in your answer.  1.01. What is the ratio of the Expenses (% of total expenses) in Goods and services in 2004 to that in 2007?
Offer a very short reply. 1.04. What is the ratio of the Expenses (% of total expenses) in Subsidies and Transfers in 2004 to that in 2007?
Offer a very short reply. 0.99. What is the ratio of the Expenses (% of total expenses) in Other expenses in 2004 to that in 2007?
Offer a very short reply. 0.67. What is the ratio of the Expenses (% of total expenses) of Compensation of employees in 2004 to that in 2008?
Your answer should be very brief. 1.02. What is the ratio of the Expenses (% of total expenses) in Goods and services in 2004 to that in 2008?
Provide a succinct answer. 0.96. What is the ratio of the Expenses (% of total expenses) of Subsidies and Transfers in 2004 to that in 2008?
Keep it short and to the point. 0.98. What is the ratio of the Expenses (% of total expenses) of Other expenses in 2004 to that in 2008?
Your response must be concise. 0.8. What is the ratio of the Expenses (% of total expenses) in Compensation of employees in 2004 to that in 2009?
Your response must be concise. 1.05. What is the ratio of the Expenses (% of total expenses) of Goods and services in 2004 to that in 2009?
Offer a very short reply. 1.05. What is the ratio of the Expenses (% of total expenses) of Subsidies and Transfers in 2004 to that in 2009?
Your answer should be compact. 0.97. What is the ratio of the Expenses (% of total expenses) in Other expenses in 2004 to that in 2009?
Offer a very short reply. 0.57. What is the ratio of the Expenses (% of total expenses) in Compensation of employees in 2004 to that in 2010?
Your response must be concise. 1.06. What is the ratio of the Expenses (% of total expenses) in Goods and services in 2004 to that in 2010?
Ensure brevity in your answer.  1. What is the ratio of the Expenses (% of total expenses) of Subsidies and Transfers in 2004 to that in 2010?
Provide a succinct answer. 0.96. What is the ratio of the Expenses (% of total expenses) of Other expenses in 2004 to that in 2010?
Ensure brevity in your answer.  0.77. What is the ratio of the Expenses (% of total expenses) of Compensation of employees in 2005 to that in 2006?
Keep it short and to the point. 0.94. What is the ratio of the Expenses (% of total expenses) of Subsidies and Transfers in 2005 to that in 2006?
Make the answer very short. 0.94. What is the ratio of the Expenses (% of total expenses) of Other expenses in 2005 to that in 2006?
Give a very brief answer. 2.94. What is the ratio of the Expenses (% of total expenses) in Compensation of employees in 2005 to that in 2007?
Offer a very short reply. 0.95. What is the ratio of the Expenses (% of total expenses) of Goods and services in 2005 to that in 2007?
Your answer should be compact. 0.95. What is the ratio of the Expenses (% of total expenses) of Subsidies and Transfers in 2005 to that in 2007?
Offer a very short reply. 0.94. What is the ratio of the Expenses (% of total expenses) of Other expenses in 2005 to that in 2007?
Keep it short and to the point. 2.97. What is the ratio of the Expenses (% of total expenses) of Compensation of employees in 2005 to that in 2008?
Offer a very short reply. 0.97. What is the ratio of the Expenses (% of total expenses) in Goods and services in 2005 to that in 2008?
Ensure brevity in your answer.  0.89. What is the ratio of the Expenses (% of total expenses) of Subsidies and Transfers in 2005 to that in 2008?
Offer a terse response. 0.93. What is the ratio of the Expenses (% of total expenses) in Other expenses in 2005 to that in 2008?
Your answer should be very brief. 3.51. What is the ratio of the Expenses (% of total expenses) in Compensation of employees in 2005 to that in 2009?
Provide a succinct answer. 0.99. What is the ratio of the Expenses (% of total expenses) of Goods and services in 2005 to that in 2009?
Offer a very short reply. 0.97. What is the ratio of the Expenses (% of total expenses) in Subsidies and Transfers in 2005 to that in 2009?
Your response must be concise. 0.92. What is the ratio of the Expenses (% of total expenses) of Other expenses in 2005 to that in 2009?
Your response must be concise. 2.5. What is the ratio of the Expenses (% of total expenses) of Goods and services in 2005 to that in 2010?
Provide a succinct answer. 0.92. What is the ratio of the Expenses (% of total expenses) of Subsidies and Transfers in 2005 to that in 2010?
Keep it short and to the point. 0.91. What is the ratio of the Expenses (% of total expenses) in Other expenses in 2005 to that in 2010?
Offer a terse response. 3.39. What is the ratio of the Expenses (% of total expenses) in Compensation of employees in 2006 to that in 2007?
Your answer should be compact. 1.02. What is the ratio of the Expenses (% of total expenses) in Goods and services in 2006 to that in 2007?
Give a very brief answer. 0.96. What is the ratio of the Expenses (% of total expenses) of Subsidies and Transfers in 2006 to that in 2007?
Offer a terse response. 0.99. What is the ratio of the Expenses (% of total expenses) of Other expenses in 2006 to that in 2007?
Give a very brief answer. 1.01. What is the ratio of the Expenses (% of total expenses) of Compensation of employees in 2006 to that in 2008?
Offer a very short reply. 1.03. What is the ratio of the Expenses (% of total expenses) in Goods and services in 2006 to that in 2008?
Your answer should be very brief. 0.9. What is the ratio of the Expenses (% of total expenses) of Subsidies and Transfers in 2006 to that in 2008?
Your response must be concise. 0.98. What is the ratio of the Expenses (% of total expenses) of Other expenses in 2006 to that in 2008?
Offer a terse response. 1.19. What is the ratio of the Expenses (% of total expenses) in Compensation of employees in 2006 to that in 2009?
Your answer should be compact. 1.05. What is the ratio of the Expenses (% of total expenses) in Goods and services in 2006 to that in 2009?
Your answer should be very brief. 0.98. What is the ratio of the Expenses (% of total expenses) in Subsidies and Transfers in 2006 to that in 2009?
Make the answer very short. 0.98. What is the ratio of the Expenses (% of total expenses) in Other expenses in 2006 to that in 2009?
Offer a very short reply. 0.85. What is the ratio of the Expenses (% of total expenses) in Compensation of employees in 2006 to that in 2010?
Give a very brief answer. 1.06. What is the ratio of the Expenses (% of total expenses) of Goods and services in 2006 to that in 2010?
Make the answer very short. 0.93. What is the ratio of the Expenses (% of total expenses) in Subsidies and Transfers in 2006 to that in 2010?
Make the answer very short. 0.97. What is the ratio of the Expenses (% of total expenses) of Other expenses in 2006 to that in 2010?
Ensure brevity in your answer.  1.15. What is the ratio of the Expenses (% of total expenses) of Compensation of employees in 2007 to that in 2008?
Give a very brief answer. 1.01. What is the ratio of the Expenses (% of total expenses) in Goods and services in 2007 to that in 2008?
Your answer should be compact. 0.93. What is the ratio of the Expenses (% of total expenses) in Subsidies and Transfers in 2007 to that in 2008?
Provide a short and direct response. 0.99. What is the ratio of the Expenses (% of total expenses) of Other expenses in 2007 to that in 2008?
Your answer should be very brief. 1.18. What is the ratio of the Expenses (% of total expenses) of Compensation of employees in 2007 to that in 2009?
Give a very brief answer. 1.04. What is the ratio of the Expenses (% of total expenses) in Goods and services in 2007 to that in 2009?
Ensure brevity in your answer.  1.01. What is the ratio of the Expenses (% of total expenses) in Other expenses in 2007 to that in 2009?
Your answer should be very brief. 0.84. What is the ratio of the Expenses (% of total expenses) of Compensation of employees in 2007 to that in 2010?
Offer a terse response. 1.05. What is the ratio of the Expenses (% of total expenses) of Goods and services in 2007 to that in 2010?
Provide a short and direct response. 0.96. What is the ratio of the Expenses (% of total expenses) in Subsidies and Transfers in 2007 to that in 2010?
Your answer should be very brief. 0.97. What is the ratio of the Expenses (% of total expenses) of Other expenses in 2007 to that in 2010?
Your response must be concise. 1.14. What is the ratio of the Expenses (% of total expenses) of Compensation of employees in 2008 to that in 2009?
Provide a succinct answer. 1.02. What is the ratio of the Expenses (% of total expenses) of Goods and services in 2008 to that in 2009?
Provide a short and direct response. 1.09. What is the ratio of the Expenses (% of total expenses) in Subsidies and Transfers in 2008 to that in 2009?
Your answer should be compact. 1. What is the ratio of the Expenses (% of total expenses) in Other expenses in 2008 to that in 2009?
Offer a terse response. 0.71. What is the ratio of the Expenses (% of total expenses) in Compensation of employees in 2008 to that in 2010?
Your answer should be very brief. 1.03. What is the ratio of the Expenses (% of total expenses) in Subsidies and Transfers in 2008 to that in 2010?
Make the answer very short. 0.98. What is the ratio of the Expenses (% of total expenses) of Other expenses in 2008 to that in 2010?
Your answer should be very brief. 0.97. What is the ratio of the Expenses (% of total expenses) of Compensation of employees in 2009 to that in 2010?
Make the answer very short. 1.01. What is the ratio of the Expenses (% of total expenses) in Goods and services in 2009 to that in 2010?
Your response must be concise. 0.95. What is the ratio of the Expenses (% of total expenses) in Subsidies and Transfers in 2009 to that in 2010?
Offer a terse response. 0.99. What is the ratio of the Expenses (% of total expenses) of Other expenses in 2009 to that in 2010?
Your answer should be compact. 1.36. What is the difference between the highest and the second highest Expenses (% of total expenses) in Compensation of employees?
Ensure brevity in your answer.  0.04. What is the difference between the highest and the second highest Expenses (% of total expenses) in Goods and services?
Keep it short and to the point. 0.09. What is the difference between the highest and the second highest Expenses (% of total expenses) of Subsidies and Transfers?
Keep it short and to the point. 1.06. What is the difference between the highest and the second highest Expenses (% of total expenses) in Other expenses?
Offer a very short reply. 4.79. What is the difference between the highest and the lowest Expenses (% of total expenses) in Compensation of employees?
Provide a succinct answer. 0.41. What is the difference between the highest and the lowest Expenses (% of total expenses) of Goods and services?
Give a very brief answer. 0.3. What is the difference between the highest and the lowest Expenses (% of total expenses) of Subsidies and Transfers?
Ensure brevity in your answer.  7.23. What is the difference between the highest and the lowest Expenses (% of total expenses) of Other expenses?
Give a very brief answer. 6.18. 